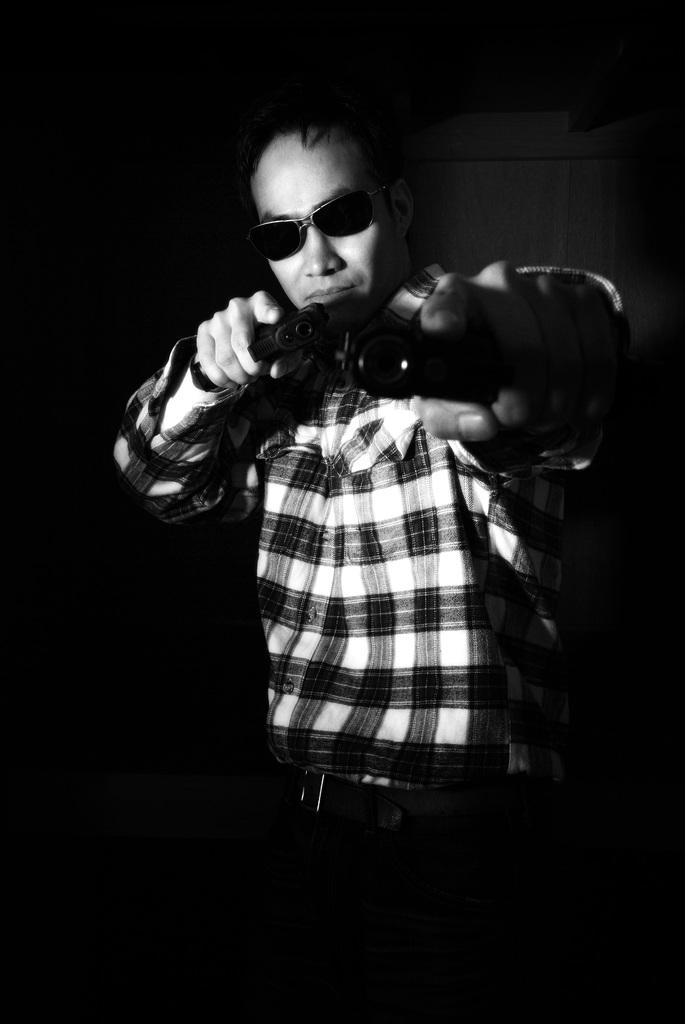Who is present in the image? There is a man in the image. What is the man doing in the image? The man is standing in the image. What is the man holding in his hands? The man is holding guns in his hands. What accessory is the man wearing in the image? The man is wearing sunglasses. What is the color of the background in the image? The background of the image is black. Can you hear the man crying in the image? There is no sound in the image, so it is not possible to hear the man crying. 